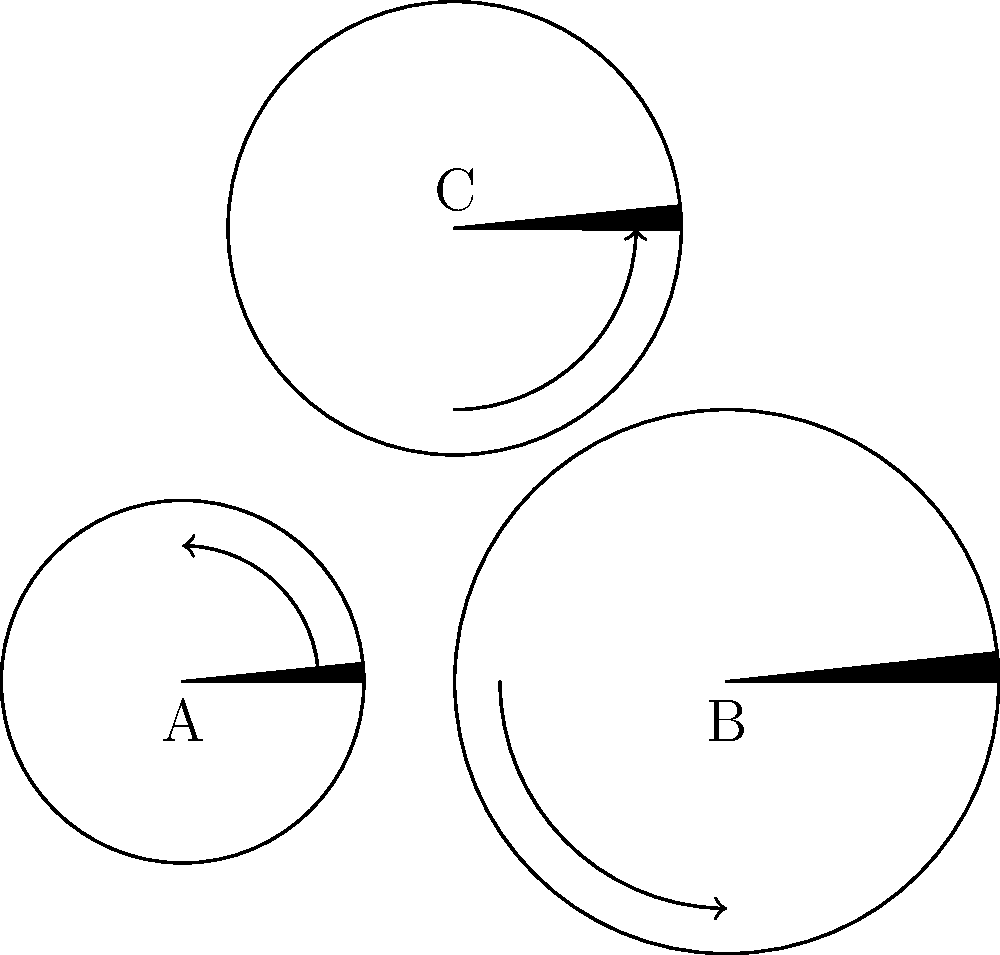In the gear system shown, gear A has 12 teeth and rotates clockwise, gear B has 18 teeth, and gear C has 15 teeth. If gear A completes 20 full rotations, how many full rotations will gear C complete? Round your answer to the nearest whole number. To solve this problem, we need to follow these steps:

1. Understand the gear relationships:
   - Gear A is connected to gear B
   - Gear B is connected to gear C
   - The number of rotations of each gear is inversely proportional to its number of teeth

2. Calculate the number of rotations of gear B:
   - Ratio of teeth: A:B = 12:18 = 2:3
   - Rotations ratio: B:A = 2:3
   - If A rotates 20 times, B rotates: $20 \times \frac{2}{3} = 13.33$ times

3. Calculate the number of rotations of gear C:
   - Ratio of teeth: B:C = 18:15 = 6:5
   - Rotations ratio: C:B = 6:5
   - If B rotates 13.33 times, C rotates: $13.33 \times \frac{6}{5} = 16$

4. Round to the nearest whole number:
   16 is already a whole number, so no rounding is necessary.

Therefore, gear C will complete 16 full rotations.
Answer: 16 